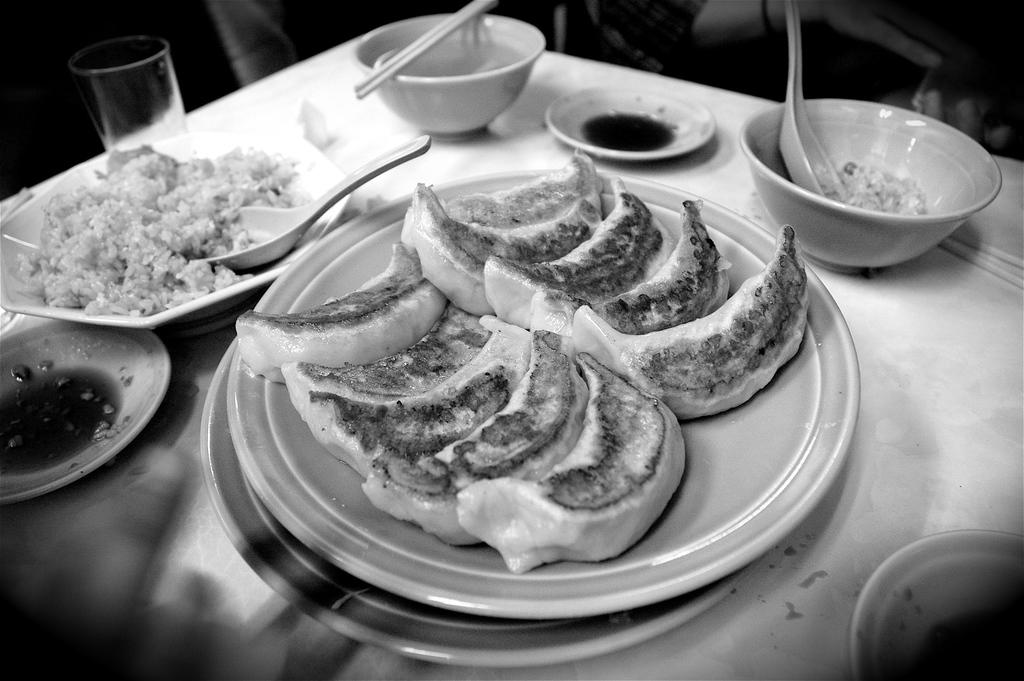What is on the plates that are visible in the image? There is food on plates in the image. What piece of furniture is present in the image? There is a table in the image. Where are the plates located in the image? The plates are on the table in the image. What type of container is present on the table? There is a glass on the table. What other type of container is present on the table? There are bowls on the table. What utensil can be seen in the image? There is a spoon in the image. What other utensil can be seen in the image? There are chopsticks in the image. What type of straw is used to decorate the table in the image? There is no straw present in the image; it only features food on plates, a table, plates, a glass, bowls, a spoon, and chopsticks. What type of rail can be seen connecting the plates in the image? There is no rail present in the image; it only features food on plates, a table, plates, a glass, bowls, a spoon, and chopsticks. 